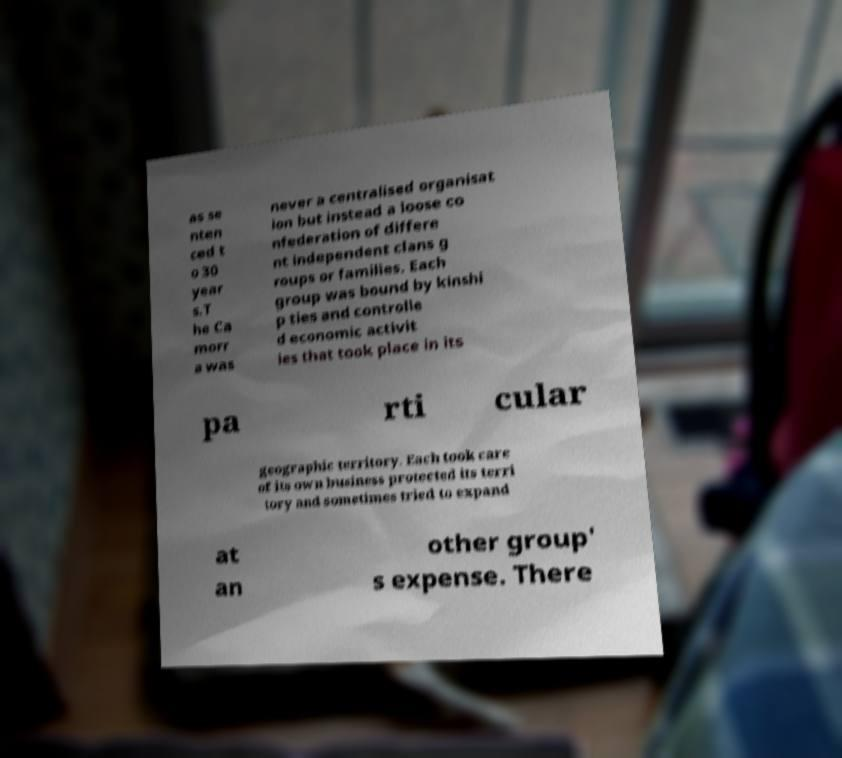Can you read and provide the text displayed in the image?This photo seems to have some interesting text. Can you extract and type it out for me? as se nten ced t o 30 year s.T he Ca morr a was never a centralised organisat ion but instead a loose co nfederation of differe nt independent clans g roups or families. Each group was bound by kinshi p ties and controlle d economic activit ies that took place in its pa rti cular geographic territory. Each took care of its own business protected its terri tory and sometimes tried to expand at an other group' s expense. There 